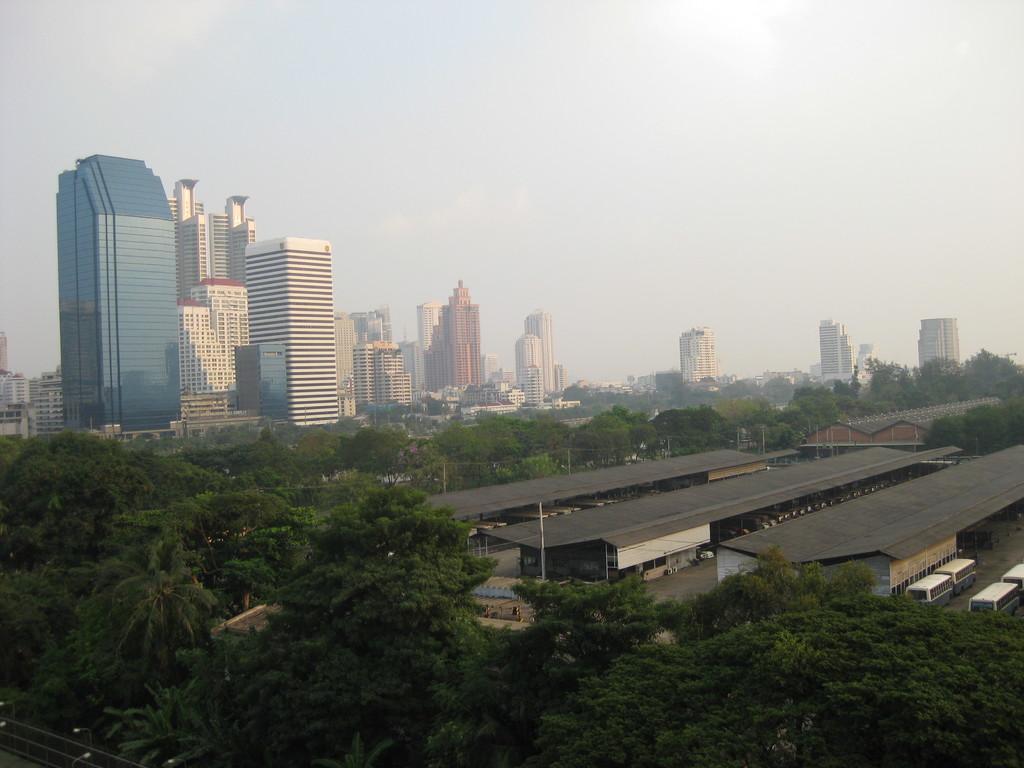Please provide a concise description of this image. This picture is clicked outside the city. At the bottom, we see the trees and street lights. In the middle of the picture, we see the buildings or sheds with grey color roofs. Beside that, we see vehicles parked on the road. There are trees and buildings in the background. At the top, we see the sky. 